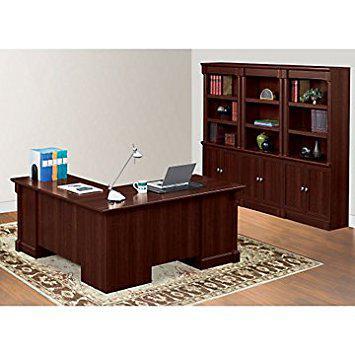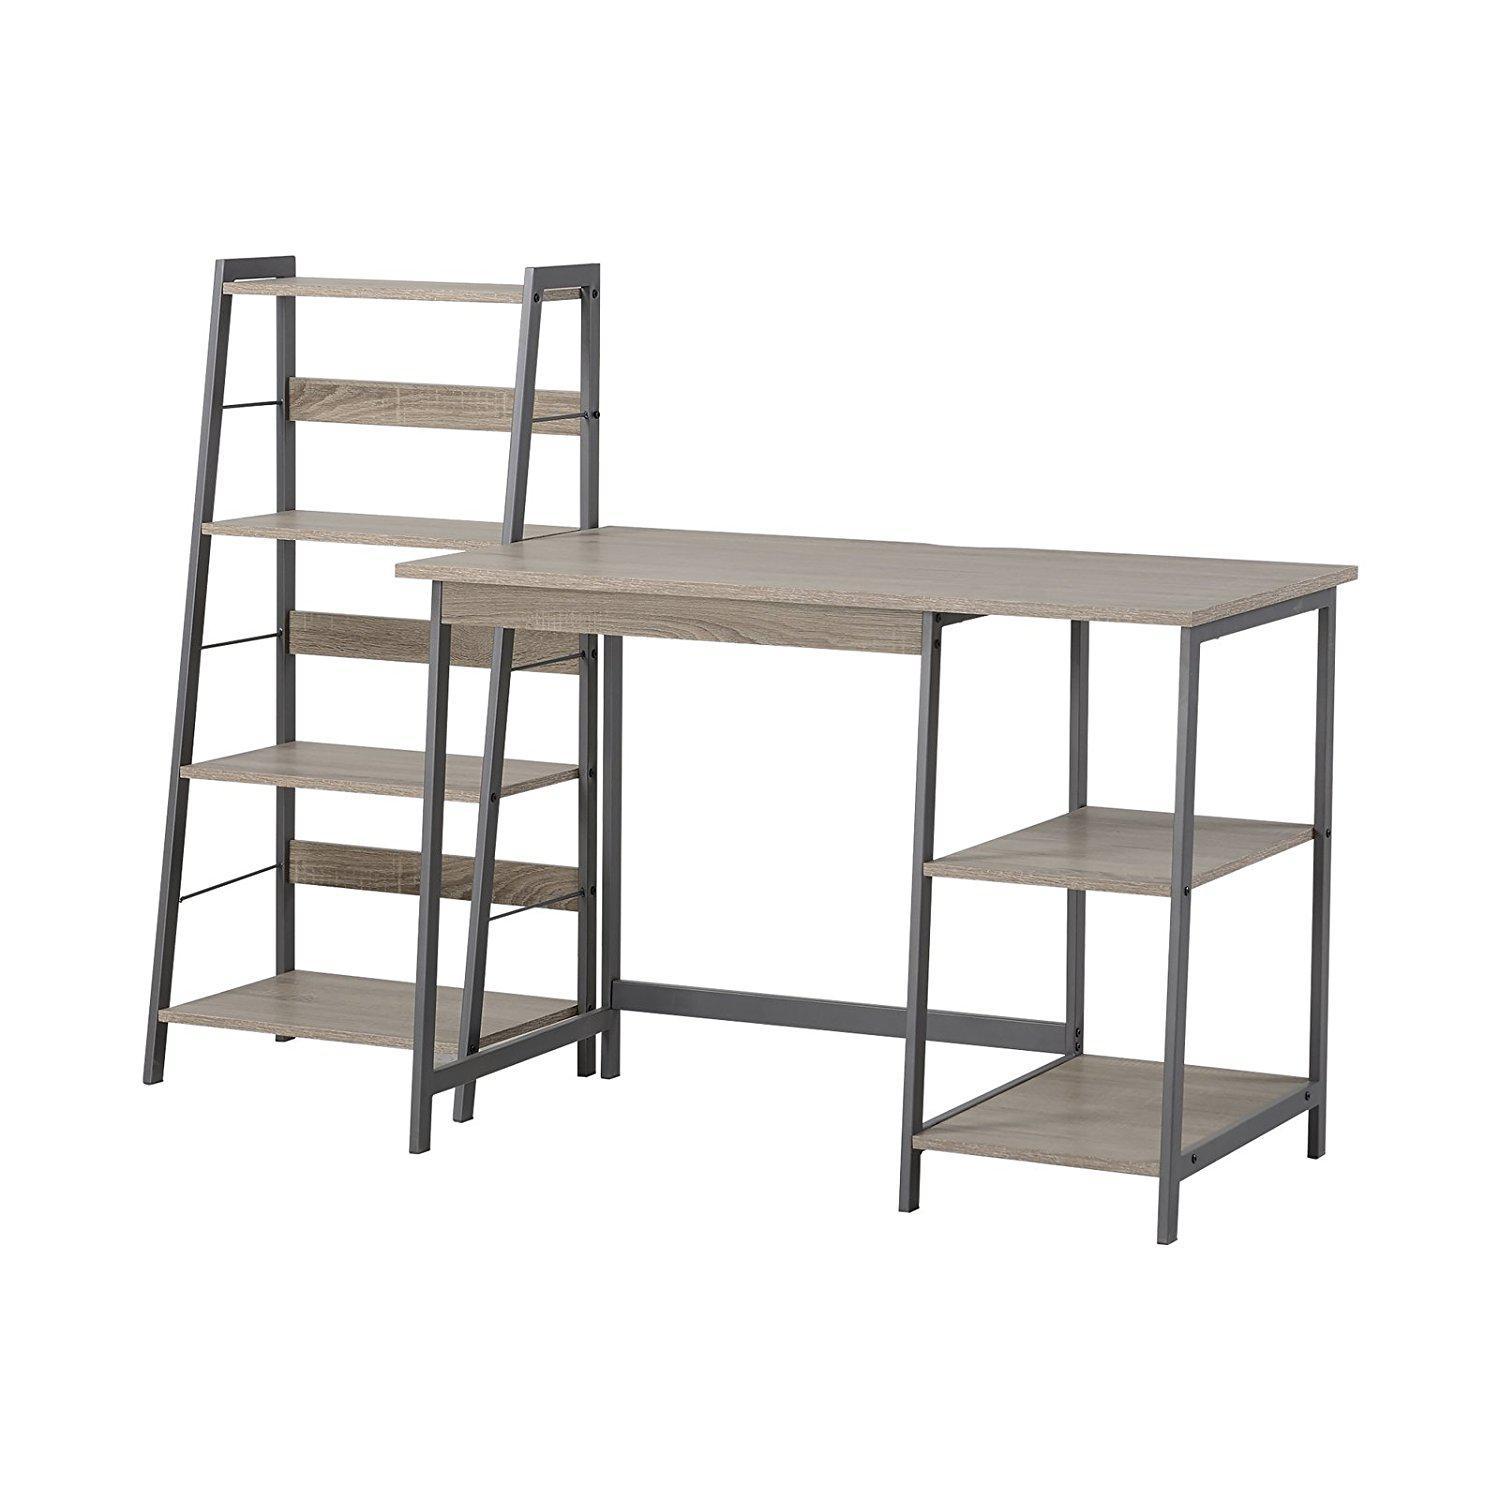The first image is the image on the left, the second image is the image on the right. Given the left and right images, does the statement "In one image a leather chair is placed at a desk unit that is attached and perpendicular to a large bookcase." hold true? Answer yes or no. No. The first image is the image on the left, the second image is the image on the right. Assess this claim about the two images: "One image includes a simple gray desk with open shelves underneath and a matching slant-front set of shelves that resembles a ladder.". Correct or not? Answer yes or no. Yes. 